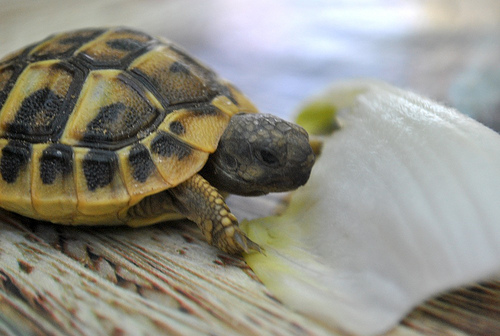<image>
Is there a table to the right of the food? Yes. From this viewpoint, the table is positioned to the right side relative to the food. 